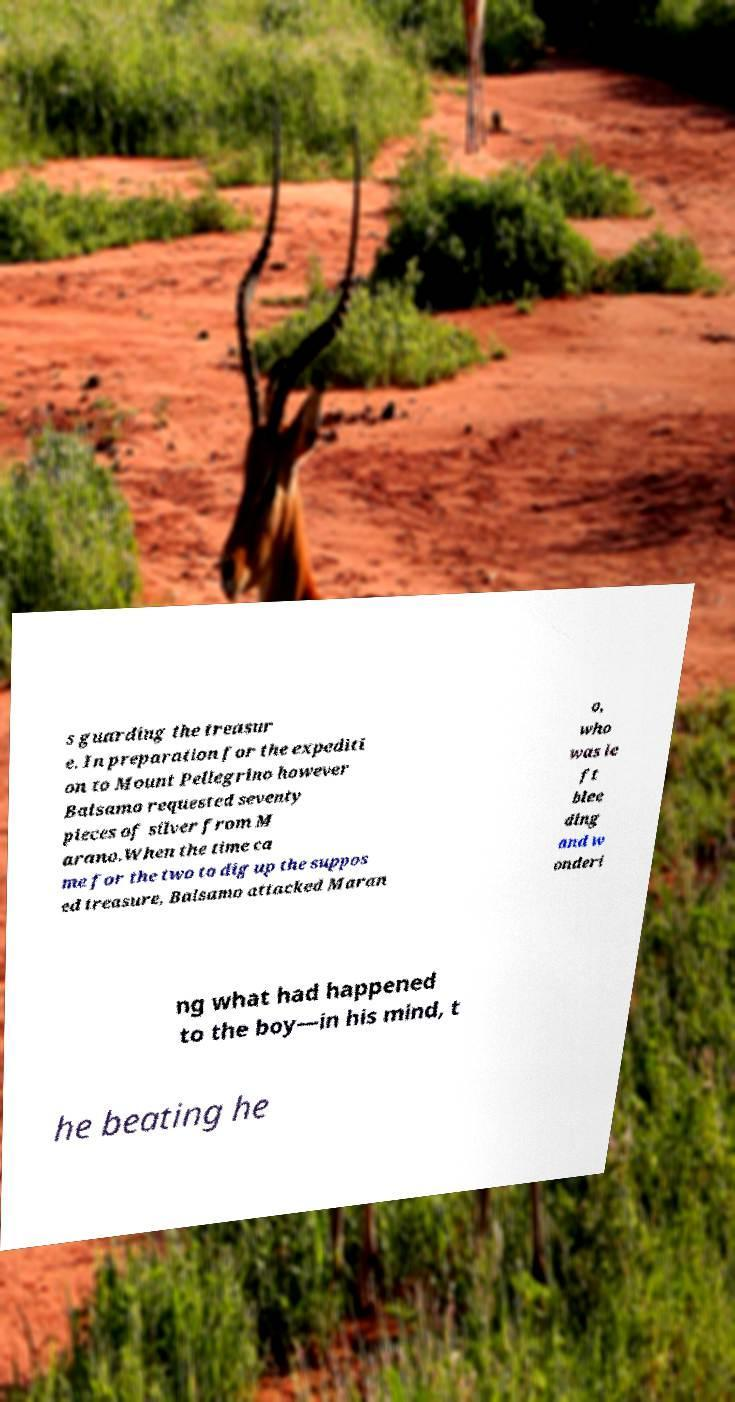For documentation purposes, I need the text within this image transcribed. Could you provide that? s guarding the treasur e. In preparation for the expediti on to Mount Pellegrino however Balsamo requested seventy pieces of silver from M arano.When the time ca me for the two to dig up the suppos ed treasure, Balsamo attacked Maran o, who was le ft blee ding and w onderi ng what had happened to the boy—in his mind, t he beating he 